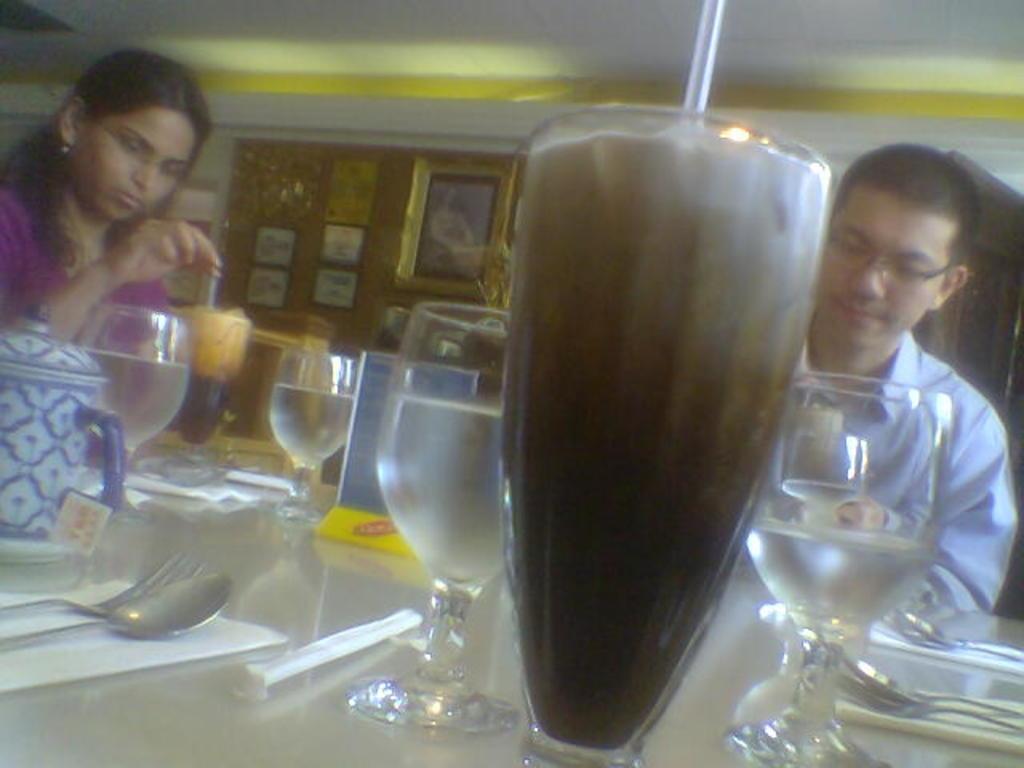In one or two sentences, can you explain what this image depicts? In the center of the image there is a beverage in tumbler placed on the table. On the right side of the image we can see tumblers, plate, spoons and person. On the left side of the image we can see tumblers, kettle, spoons, fork and a person. In the background there are photo frames and wall. 